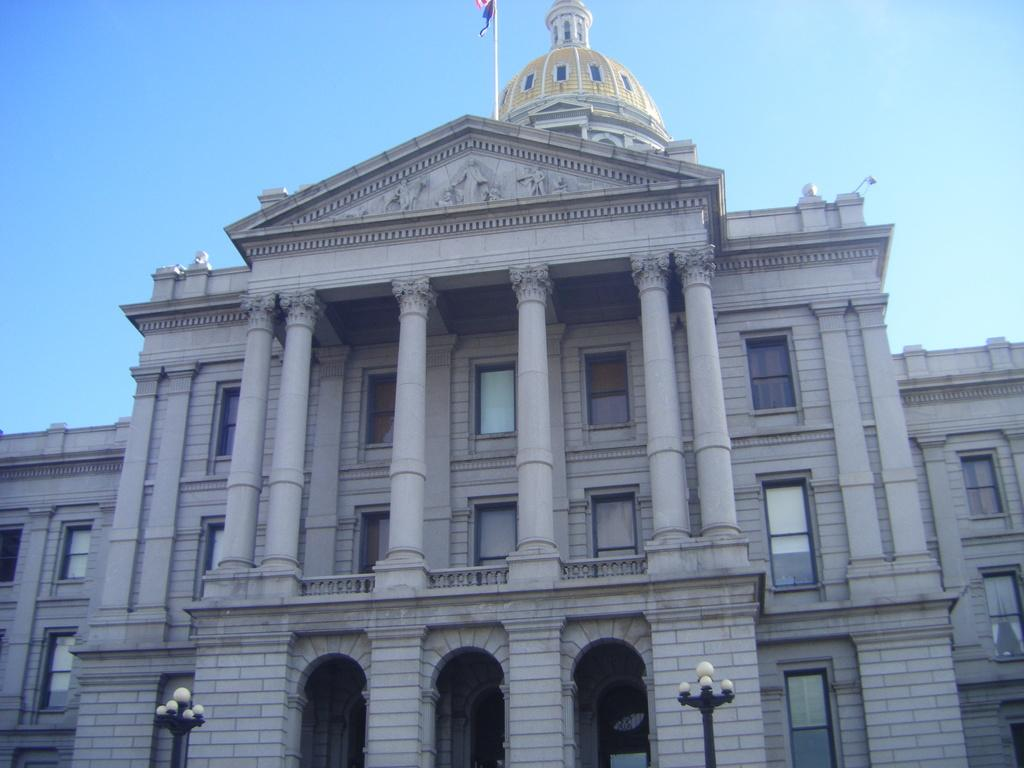What is the color of the building in the image? The building in the image is white. Are there any additional features on the building? Yes, there is a flag on the building. What type of lighting can be seen in the image? There are street lights in the image. What can be seen in the background of the image? The sky is visible in the background of the image. How many legs does the cannon have in the image? There is no cannon present in the image. What type of toothbrush is visible in the image? There is no toothbrush present in the image. 